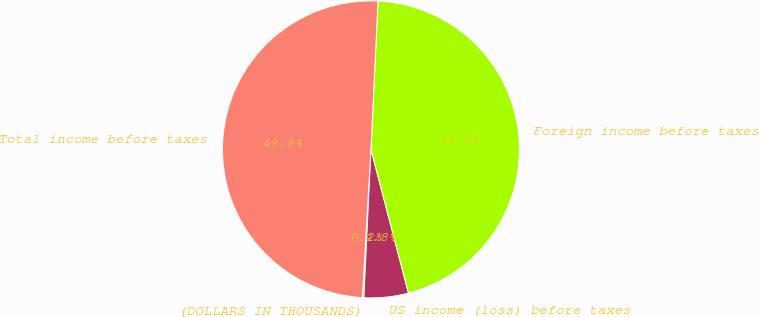Convert chart. <chart><loc_0><loc_0><loc_500><loc_500><pie_chart><fcel>(DOLLARS IN THOUSANDS)<fcel>US income (loss) before taxes<fcel>Foreign income before taxes<fcel>Total income before taxes<nl><fcel>0.17%<fcel>4.82%<fcel>45.18%<fcel>49.83%<nl></chart> 